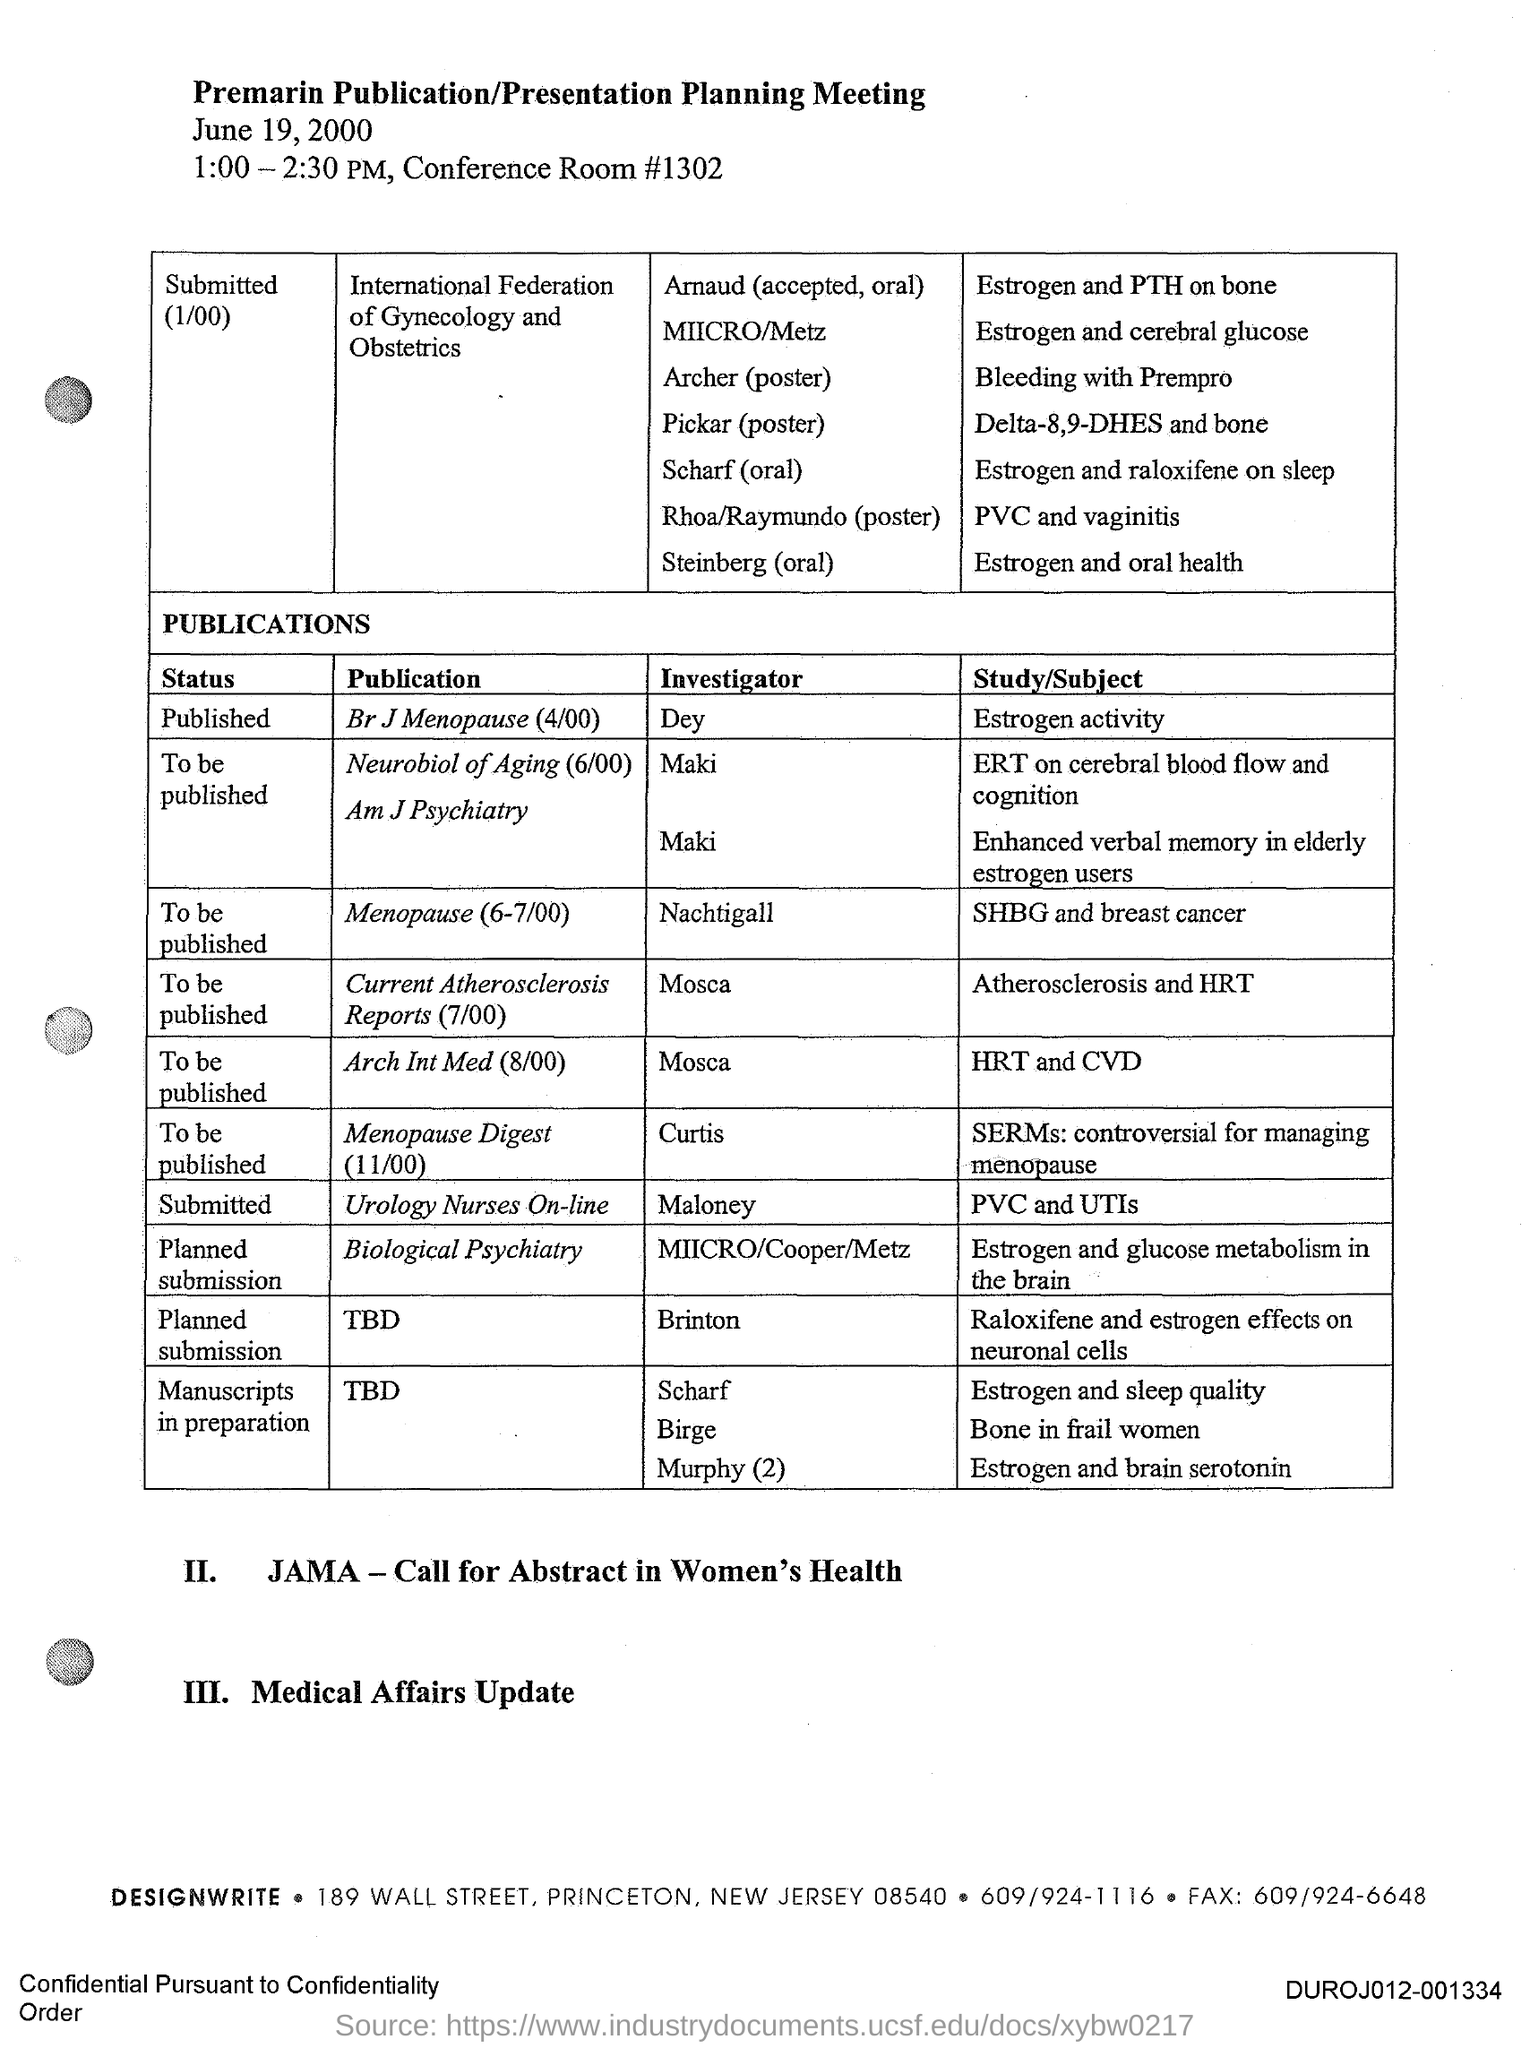What is the title of the document?
Your response must be concise. Premarin Publication/Presentation Planning Meeting. Who is the Investigator for the publication Br J Menopause(4/00)?
Keep it short and to the point. Dey. Who is the Investigator for the publication Menopause(6-7/100)?
Offer a terse response. Nachtigall. 